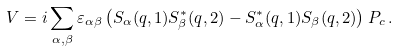<formula> <loc_0><loc_0><loc_500><loc_500>V = i \sum _ { \alpha , \beta } \varepsilon _ { \alpha \beta } \left ( S _ { \alpha } ( { q } , 1 ) S ^ { * } _ { \beta } ( { q } , 2 ) - S ^ { * } _ { \alpha } ( { q } , 1 ) S _ { \beta } ( { q } , 2 ) \right ) P _ { c } \, .</formula> 